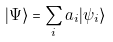<formula> <loc_0><loc_0><loc_500><loc_500>| \Psi \rangle = \sum _ { i } a _ { i } | \psi _ { i } \rangle</formula> 